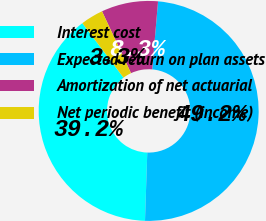Convert chart to OTSL. <chart><loc_0><loc_0><loc_500><loc_500><pie_chart><fcel>Interest cost<fcel>Expected return on plan assets<fcel>Amortization of net actuarial<fcel>Net periodic benefit (income)<nl><fcel>39.17%<fcel>49.17%<fcel>8.33%<fcel>3.33%<nl></chart> 